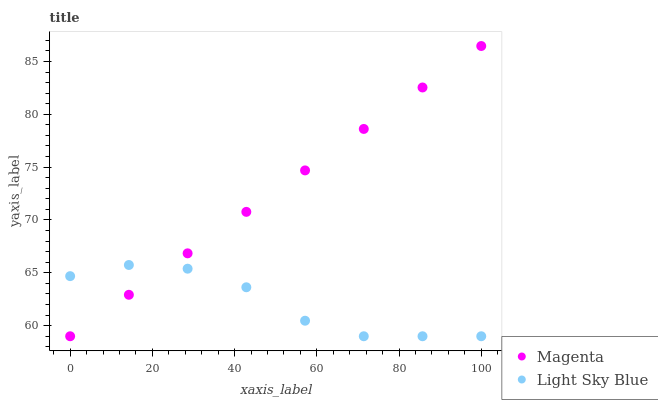Does Light Sky Blue have the minimum area under the curve?
Answer yes or no. Yes. Does Magenta have the maximum area under the curve?
Answer yes or no. Yes. Does Light Sky Blue have the maximum area under the curve?
Answer yes or no. No. Is Magenta the smoothest?
Answer yes or no. Yes. Is Light Sky Blue the roughest?
Answer yes or no. Yes. Is Light Sky Blue the smoothest?
Answer yes or no. No. Does Magenta have the lowest value?
Answer yes or no. Yes. Does Magenta have the highest value?
Answer yes or no. Yes. Does Light Sky Blue have the highest value?
Answer yes or no. No. Does Magenta intersect Light Sky Blue?
Answer yes or no. Yes. Is Magenta less than Light Sky Blue?
Answer yes or no. No. Is Magenta greater than Light Sky Blue?
Answer yes or no. No. 